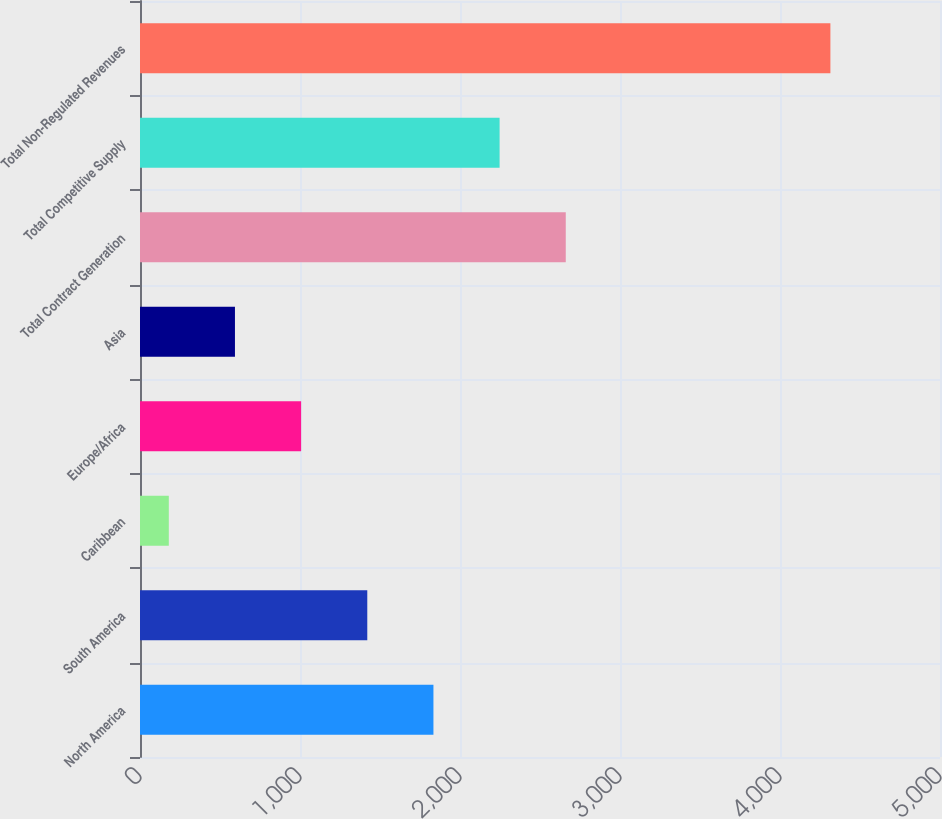<chart> <loc_0><loc_0><loc_500><loc_500><bar_chart><fcel>North America<fcel>South America<fcel>Caribbean<fcel>Europe/Africa<fcel>Asia<fcel>Total Contract Generation<fcel>Total Competitive Supply<fcel>Total Non-Regulated Revenues<nl><fcel>1834<fcel>1420.5<fcel>180<fcel>1007<fcel>593.5<fcel>2661<fcel>2247.5<fcel>4315<nl></chart> 